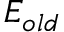<formula> <loc_0><loc_0><loc_500><loc_500>E _ { o l d }</formula> 